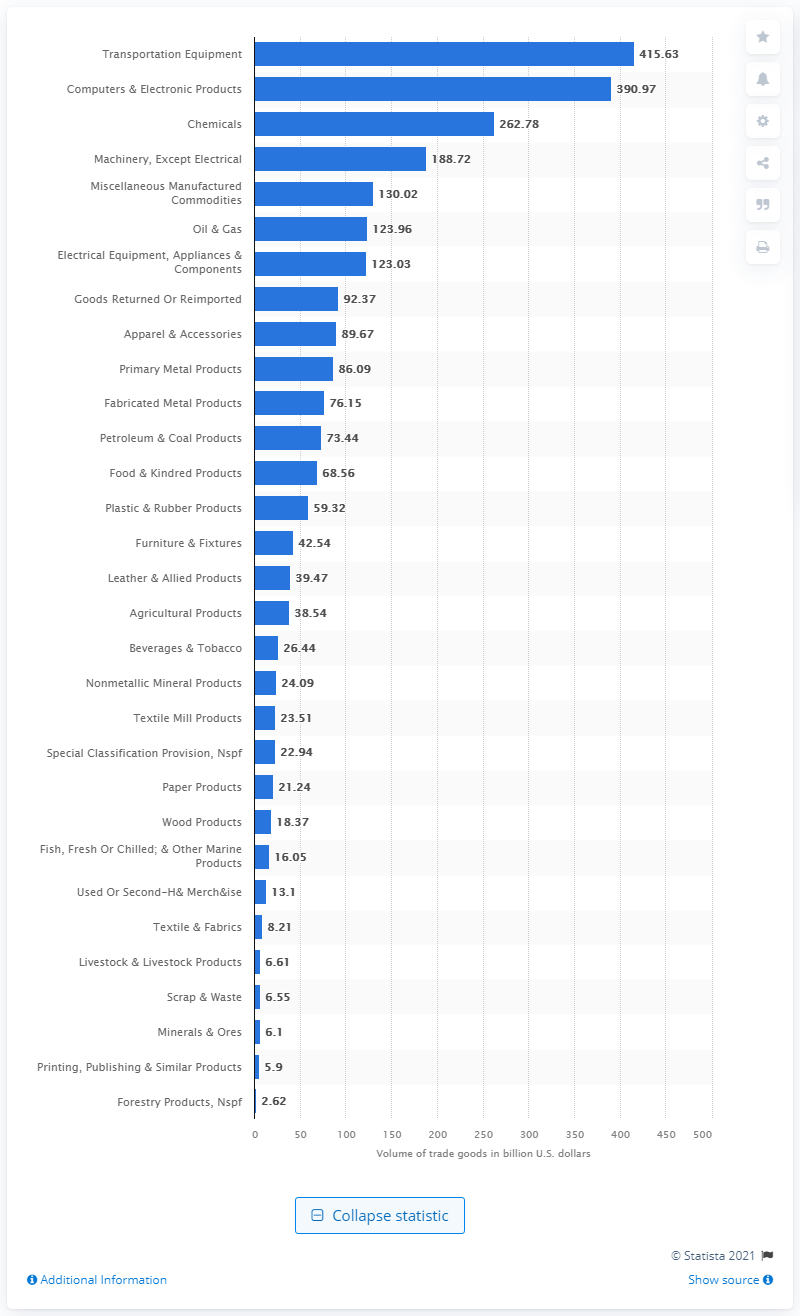List a handful of essential elements in this visual. In 2019, the value of transportation equipment in the United States was 415.63 million U.S. dollars. 